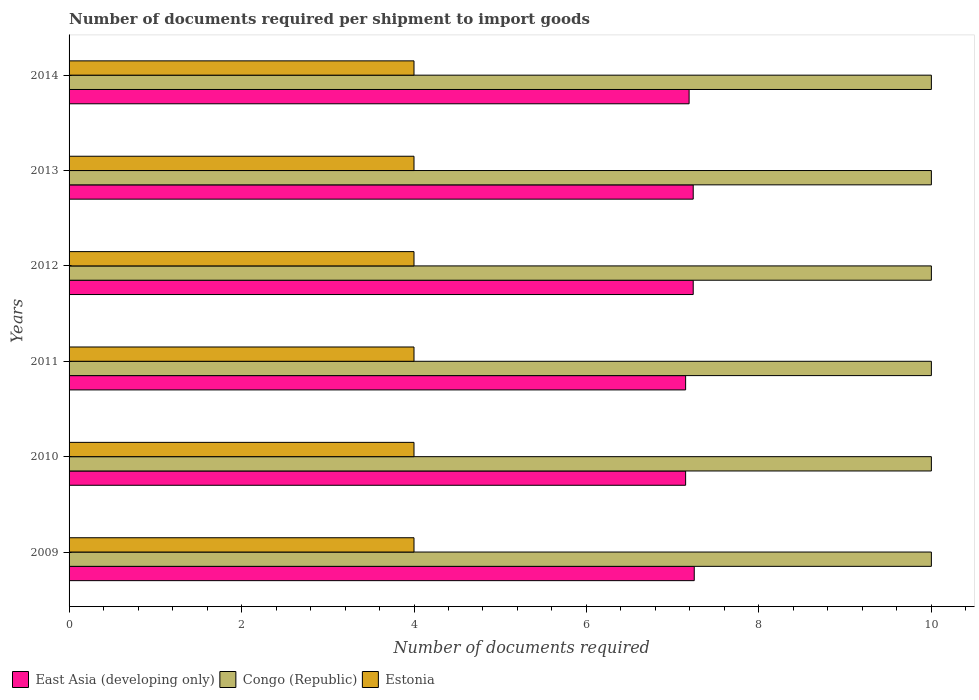Are the number of bars per tick equal to the number of legend labels?
Give a very brief answer. Yes. How many bars are there on the 4th tick from the top?
Your response must be concise. 3. What is the label of the 5th group of bars from the top?
Provide a succinct answer. 2010. What is the number of documents required per shipment to import goods in Estonia in 2013?
Make the answer very short. 4. Across all years, what is the maximum number of documents required per shipment to import goods in East Asia (developing only)?
Make the answer very short. 7.25. Across all years, what is the minimum number of documents required per shipment to import goods in East Asia (developing only)?
Make the answer very short. 7.15. In which year was the number of documents required per shipment to import goods in East Asia (developing only) maximum?
Make the answer very short. 2009. In which year was the number of documents required per shipment to import goods in Estonia minimum?
Your response must be concise. 2009. What is the total number of documents required per shipment to import goods in Congo (Republic) in the graph?
Offer a terse response. 60. What is the difference between the number of documents required per shipment to import goods in Congo (Republic) in 2009 and the number of documents required per shipment to import goods in East Asia (developing only) in 2014?
Ensure brevity in your answer.  2.81. In the year 2010, what is the difference between the number of documents required per shipment to import goods in Congo (Republic) and number of documents required per shipment to import goods in Estonia?
Make the answer very short. 6. In how many years, is the number of documents required per shipment to import goods in Congo (Republic) greater than 5.2 ?
Provide a succinct answer. 6. What is the ratio of the number of documents required per shipment to import goods in East Asia (developing only) in 2013 to that in 2014?
Your response must be concise. 1.01. Is the difference between the number of documents required per shipment to import goods in Congo (Republic) in 2009 and 2010 greater than the difference between the number of documents required per shipment to import goods in Estonia in 2009 and 2010?
Offer a terse response. No. What is the difference between the highest and the lowest number of documents required per shipment to import goods in Estonia?
Make the answer very short. 0. In how many years, is the number of documents required per shipment to import goods in Estonia greater than the average number of documents required per shipment to import goods in Estonia taken over all years?
Ensure brevity in your answer.  0. Is the sum of the number of documents required per shipment to import goods in East Asia (developing only) in 2011 and 2014 greater than the maximum number of documents required per shipment to import goods in Estonia across all years?
Make the answer very short. Yes. What does the 2nd bar from the top in 2013 represents?
Ensure brevity in your answer.  Congo (Republic). What does the 2nd bar from the bottom in 2013 represents?
Offer a very short reply. Congo (Republic). Is it the case that in every year, the sum of the number of documents required per shipment to import goods in East Asia (developing only) and number of documents required per shipment to import goods in Estonia is greater than the number of documents required per shipment to import goods in Congo (Republic)?
Your response must be concise. Yes. How many bars are there?
Offer a terse response. 18. Are all the bars in the graph horizontal?
Provide a succinct answer. Yes. Does the graph contain any zero values?
Your answer should be compact. No. Does the graph contain grids?
Ensure brevity in your answer.  No. How many legend labels are there?
Keep it short and to the point. 3. How are the legend labels stacked?
Offer a terse response. Horizontal. What is the title of the graph?
Ensure brevity in your answer.  Number of documents required per shipment to import goods. Does "Fragile and conflict affected situations" appear as one of the legend labels in the graph?
Make the answer very short. No. What is the label or title of the X-axis?
Ensure brevity in your answer.  Number of documents required. What is the Number of documents required of East Asia (developing only) in 2009?
Your answer should be compact. 7.25. What is the Number of documents required of Congo (Republic) in 2009?
Your answer should be compact. 10. What is the Number of documents required of Estonia in 2009?
Your response must be concise. 4. What is the Number of documents required of East Asia (developing only) in 2010?
Your response must be concise. 7.15. What is the Number of documents required of East Asia (developing only) in 2011?
Offer a terse response. 7.15. What is the Number of documents required of Congo (Republic) in 2011?
Make the answer very short. 10. What is the Number of documents required in Estonia in 2011?
Your answer should be very brief. 4. What is the Number of documents required in East Asia (developing only) in 2012?
Offer a very short reply. 7.24. What is the Number of documents required of Congo (Republic) in 2012?
Your answer should be very brief. 10. What is the Number of documents required in East Asia (developing only) in 2013?
Your response must be concise. 7.24. What is the Number of documents required of Estonia in 2013?
Make the answer very short. 4. What is the Number of documents required of East Asia (developing only) in 2014?
Provide a succinct answer. 7.19. What is the Number of documents required in Congo (Republic) in 2014?
Ensure brevity in your answer.  10. What is the Number of documents required of Estonia in 2014?
Your answer should be compact. 4. Across all years, what is the maximum Number of documents required in East Asia (developing only)?
Your answer should be compact. 7.25. Across all years, what is the maximum Number of documents required in Congo (Republic)?
Ensure brevity in your answer.  10. Across all years, what is the minimum Number of documents required in East Asia (developing only)?
Your answer should be very brief. 7.15. Across all years, what is the minimum Number of documents required of Congo (Republic)?
Ensure brevity in your answer.  10. Across all years, what is the minimum Number of documents required of Estonia?
Keep it short and to the point. 4. What is the total Number of documents required of East Asia (developing only) in the graph?
Provide a short and direct response. 43.22. What is the difference between the Number of documents required of Congo (Republic) in 2009 and that in 2011?
Make the answer very short. 0. What is the difference between the Number of documents required of Estonia in 2009 and that in 2011?
Your response must be concise. 0. What is the difference between the Number of documents required in East Asia (developing only) in 2009 and that in 2012?
Ensure brevity in your answer.  0.01. What is the difference between the Number of documents required in East Asia (developing only) in 2009 and that in 2013?
Give a very brief answer. 0.01. What is the difference between the Number of documents required of Congo (Republic) in 2009 and that in 2013?
Give a very brief answer. 0. What is the difference between the Number of documents required in East Asia (developing only) in 2009 and that in 2014?
Provide a succinct answer. 0.06. What is the difference between the Number of documents required of Estonia in 2009 and that in 2014?
Your answer should be very brief. 0. What is the difference between the Number of documents required of East Asia (developing only) in 2010 and that in 2012?
Offer a very short reply. -0.09. What is the difference between the Number of documents required of East Asia (developing only) in 2010 and that in 2013?
Offer a very short reply. -0.09. What is the difference between the Number of documents required in Congo (Republic) in 2010 and that in 2013?
Provide a short and direct response. 0. What is the difference between the Number of documents required in East Asia (developing only) in 2010 and that in 2014?
Ensure brevity in your answer.  -0.04. What is the difference between the Number of documents required in East Asia (developing only) in 2011 and that in 2012?
Provide a succinct answer. -0.09. What is the difference between the Number of documents required of Estonia in 2011 and that in 2012?
Your response must be concise. 0. What is the difference between the Number of documents required of East Asia (developing only) in 2011 and that in 2013?
Offer a very short reply. -0.09. What is the difference between the Number of documents required in Congo (Republic) in 2011 and that in 2013?
Provide a short and direct response. 0. What is the difference between the Number of documents required in Estonia in 2011 and that in 2013?
Offer a very short reply. 0. What is the difference between the Number of documents required in East Asia (developing only) in 2011 and that in 2014?
Make the answer very short. -0.04. What is the difference between the Number of documents required in Estonia in 2011 and that in 2014?
Your response must be concise. 0. What is the difference between the Number of documents required of Estonia in 2012 and that in 2013?
Your answer should be very brief. 0. What is the difference between the Number of documents required of East Asia (developing only) in 2012 and that in 2014?
Offer a terse response. 0.05. What is the difference between the Number of documents required of Congo (Republic) in 2012 and that in 2014?
Keep it short and to the point. 0. What is the difference between the Number of documents required of East Asia (developing only) in 2013 and that in 2014?
Your answer should be compact. 0.05. What is the difference between the Number of documents required of East Asia (developing only) in 2009 and the Number of documents required of Congo (Republic) in 2010?
Offer a terse response. -2.75. What is the difference between the Number of documents required in East Asia (developing only) in 2009 and the Number of documents required in Estonia in 2010?
Your answer should be compact. 3.25. What is the difference between the Number of documents required in Congo (Republic) in 2009 and the Number of documents required in Estonia in 2010?
Keep it short and to the point. 6. What is the difference between the Number of documents required of East Asia (developing only) in 2009 and the Number of documents required of Congo (Republic) in 2011?
Provide a short and direct response. -2.75. What is the difference between the Number of documents required of East Asia (developing only) in 2009 and the Number of documents required of Congo (Republic) in 2012?
Provide a succinct answer. -2.75. What is the difference between the Number of documents required of East Asia (developing only) in 2009 and the Number of documents required of Estonia in 2012?
Give a very brief answer. 3.25. What is the difference between the Number of documents required of Congo (Republic) in 2009 and the Number of documents required of Estonia in 2012?
Provide a succinct answer. 6. What is the difference between the Number of documents required in East Asia (developing only) in 2009 and the Number of documents required in Congo (Republic) in 2013?
Keep it short and to the point. -2.75. What is the difference between the Number of documents required of Congo (Republic) in 2009 and the Number of documents required of Estonia in 2013?
Ensure brevity in your answer.  6. What is the difference between the Number of documents required in East Asia (developing only) in 2009 and the Number of documents required in Congo (Republic) in 2014?
Your answer should be compact. -2.75. What is the difference between the Number of documents required of East Asia (developing only) in 2009 and the Number of documents required of Estonia in 2014?
Offer a terse response. 3.25. What is the difference between the Number of documents required of East Asia (developing only) in 2010 and the Number of documents required of Congo (Republic) in 2011?
Provide a succinct answer. -2.85. What is the difference between the Number of documents required in East Asia (developing only) in 2010 and the Number of documents required in Estonia in 2011?
Provide a succinct answer. 3.15. What is the difference between the Number of documents required in Congo (Republic) in 2010 and the Number of documents required in Estonia in 2011?
Make the answer very short. 6. What is the difference between the Number of documents required of East Asia (developing only) in 2010 and the Number of documents required of Congo (Republic) in 2012?
Your answer should be very brief. -2.85. What is the difference between the Number of documents required in East Asia (developing only) in 2010 and the Number of documents required in Estonia in 2012?
Make the answer very short. 3.15. What is the difference between the Number of documents required in East Asia (developing only) in 2010 and the Number of documents required in Congo (Republic) in 2013?
Keep it short and to the point. -2.85. What is the difference between the Number of documents required in East Asia (developing only) in 2010 and the Number of documents required in Estonia in 2013?
Your answer should be very brief. 3.15. What is the difference between the Number of documents required in East Asia (developing only) in 2010 and the Number of documents required in Congo (Republic) in 2014?
Your answer should be very brief. -2.85. What is the difference between the Number of documents required in East Asia (developing only) in 2010 and the Number of documents required in Estonia in 2014?
Make the answer very short. 3.15. What is the difference between the Number of documents required in Congo (Republic) in 2010 and the Number of documents required in Estonia in 2014?
Your answer should be very brief. 6. What is the difference between the Number of documents required of East Asia (developing only) in 2011 and the Number of documents required of Congo (Republic) in 2012?
Provide a succinct answer. -2.85. What is the difference between the Number of documents required of East Asia (developing only) in 2011 and the Number of documents required of Estonia in 2012?
Keep it short and to the point. 3.15. What is the difference between the Number of documents required of Congo (Republic) in 2011 and the Number of documents required of Estonia in 2012?
Your answer should be very brief. 6. What is the difference between the Number of documents required in East Asia (developing only) in 2011 and the Number of documents required in Congo (Republic) in 2013?
Ensure brevity in your answer.  -2.85. What is the difference between the Number of documents required in East Asia (developing only) in 2011 and the Number of documents required in Estonia in 2013?
Offer a terse response. 3.15. What is the difference between the Number of documents required of Congo (Republic) in 2011 and the Number of documents required of Estonia in 2013?
Ensure brevity in your answer.  6. What is the difference between the Number of documents required of East Asia (developing only) in 2011 and the Number of documents required of Congo (Republic) in 2014?
Keep it short and to the point. -2.85. What is the difference between the Number of documents required in East Asia (developing only) in 2011 and the Number of documents required in Estonia in 2014?
Keep it short and to the point. 3.15. What is the difference between the Number of documents required of Congo (Republic) in 2011 and the Number of documents required of Estonia in 2014?
Your answer should be compact. 6. What is the difference between the Number of documents required in East Asia (developing only) in 2012 and the Number of documents required in Congo (Republic) in 2013?
Offer a terse response. -2.76. What is the difference between the Number of documents required in East Asia (developing only) in 2012 and the Number of documents required in Estonia in 2013?
Ensure brevity in your answer.  3.24. What is the difference between the Number of documents required in East Asia (developing only) in 2012 and the Number of documents required in Congo (Republic) in 2014?
Offer a terse response. -2.76. What is the difference between the Number of documents required of East Asia (developing only) in 2012 and the Number of documents required of Estonia in 2014?
Make the answer very short. 3.24. What is the difference between the Number of documents required of East Asia (developing only) in 2013 and the Number of documents required of Congo (Republic) in 2014?
Your response must be concise. -2.76. What is the difference between the Number of documents required of East Asia (developing only) in 2013 and the Number of documents required of Estonia in 2014?
Offer a terse response. 3.24. What is the difference between the Number of documents required in Congo (Republic) in 2013 and the Number of documents required in Estonia in 2014?
Make the answer very short. 6. What is the average Number of documents required of East Asia (developing only) per year?
Keep it short and to the point. 7.2. What is the average Number of documents required in Congo (Republic) per year?
Your answer should be very brief. 10. What is the average Number of documents required of Estonia per year?
Your answer should be compact. 4. In the year 2009, what is the difference between the Number of documents required in East Asia (developing only) and Number of documents required in Congo (Republic)?
Keep it short and to the point. -2.75. In the year 2010, what is the difference between the Number of documents required of East Asia (developing only) and Number of documents required of Congo (Republic)?
Your answer should be very brief. -2.85. In the year 2010, what is the difference between the Number of documents required in East Asia (developing only) and Number of documents required in Estonia?
Your answer should be very brief. 3.15. In the year 2010, what is the difference between the Number of documents required of Congo (Republic) and Number of documents required of Estonia?
Ensure brevity in your answer.  6. In the year 2011, what is the difference between the Number of documents required of East Asia (developing only) and Number of documents required of Congo (Republic)?
Make the answer very short. -2.85. In the year 2011, what is the difference between the Number of documents required of East Asia (developing only) and Number of documents required of Estonia?
Give a very brief answer. 3.15. In the year 2011, what is the difference between the Number of documents required in Congo (Republic) and Number of documents required in Estonia?
Offer a terse response. 6. In the year 2012, what is the difference between the Number of documents required in East Asia (developing only) and Number of documents required in Congo (Republic)?
Offer a very short reply. -2.76. In the year 2012, what is the difference between the Number of documents required in East Asia (developing only) and Number of documents required in Estonia?
Your answer should be very brief. 3.24. In the year 2013, what is the difference between the Number of documents required of East Asia (developing only) and Number of documents required of Congo (Republic)?
Ensure brevity in your answer.  -2.76. In the year 2013, what is the difference between the Number of documents required in East Asia (developing only) and Number of documents required in Estonia?
Make the answer very short. 3.24. In the year 2013, what is the difference between the Number of documents required of Congo (Republic) and Number of documents required of Estonia?
Provide a succinct answer. 6. In the year 2014, what is the difference between the Number of documents required of East Asia (developing only) and Number of documents required of Congo (Republic)?
Provide a succinct answer. -2.81. In the year 2014, what is the difference between the Number of documents required in East Asia (developing only) and Number of documents required in Estonia?
Offer a very short reply. 3.19. In the year 2014, what is the difference between the Number of documents required of Congo (Republic) and Number of documents required of Estonia?
Your response must be concise. 6. What is the ratio of the Number of documents required in East Asia (developing only) in 2009 to that in 2010?
Offer a terse response. 1.01. What is the ratio of the Number of documents required of Estonia in 2009 to that in 2010?
Provide a succinct answer. 1. What is the ratio of the Number of documents required in East Asia (developing only) in 2009 to that in 2011?
Offer a very short reply. 1.01. What is the ratio of the Number of documents required in Estonia in 2009 to that in 2011?
Your answer should be very brief. 1. What is the ratio of the Number of documents required in Estonia in 2009 to that in 2012?
Your answer should be very brief. 1. What is the ratio of the Number of documents required of Estonia in 2009 to that in 2013?
Give a very brief answer. 1. What is the ratio of the Number of documents required in East Asia (developing only) in 2009 to that in 2014?
Provide a succinct answer. 1.01. What is the ratio of the Number of documents required of East Asia (developing only) in 2010 to that in 2011?
Provide a succinct answer. 1. What is the ratio of the Number of documents required of Congo (Republic) in 2010 to that in 2012?
Offer a very short reply. 1. What is the ratio of the Number of documents required of Estonia in 2010 to that in 2012?
Provide a short and direct response. 1. What is the ratio of the Number of documents required in Estonia in 2010 to that in 2013?
Your answer should be very brief. 1. What is the ratio of the Number of documents required of East Asia (developing only) in 2010 to that in 2014?
Your answer should be compact. 0.99. What is the ratio of the Number of documents required in Estonia in 2010 to that in 2014?
Offer a terse response. 1. What is the ratio of the Number of documents required in Congo (Republic) in 2011 to that in 2013?
Offer a very short reply. 1. What is the ratio of the Number of documents required of East Asia (developing only) in 2011 to that in 2014?
Your answer should be compact. 0.99. What is the ratio of the Number of documents required of Congo (Republic) in 2012 to that in 2013?
Keep it short and to the point. 1. What is the ratio of the Number of documents required of East Asia (developing only) in 2012 to that in 2014?
Provide a short and direct response. 1.01. What is the ratio of the Number of documents required of Congo (Republic) in 2012 to that in 2014?
Your answer should be very brief. 1. What is the ratio of the Number of documents required of Estonia in 2012 to that in 2014?
Keep it short and to the point. 1. What is the ratio of the Number of documents required of East Asia (developing only) in 2013 to that in 2014?
Your answer should be compact. 1.01. What is the ratio of the Number of documents required in Estonia in 2013 to that in 2014?
Ensure brevity in your answer.  1. What is the difference between the highest and the second highest Number of documents required of East Asia (developing only)?
Give a very brief answer. 0.01. What is the difference between the highest and the second highest Number of documents required in Estonia?
Make the answer very short. 0. What is the difference between the highest and the lowest Number of documents required in Congo (Republic)?
Your response must be concise. 0. What is the difference between the highest and the lowest Number of documents required in Estonia?
Provide a short and direct response. 0. 